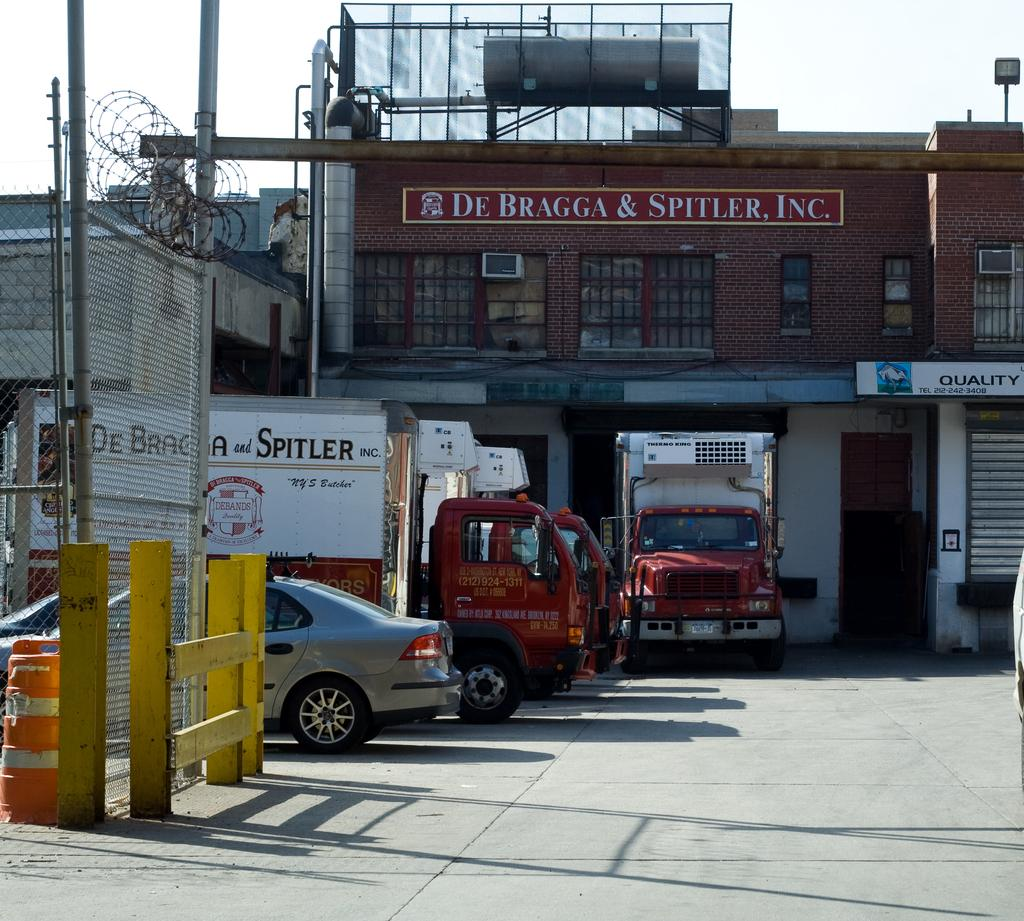<image>
Create a compact narrative representing the image presented. A truck is parked under a sign named De Bragga & Spitler, Inc. 